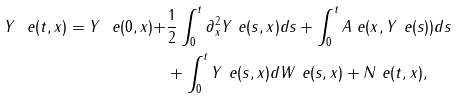Convert formula to latex. <formula><loc_0><loc_0><loc_500><loc_500>Y ^ { \ } e ( t , x ) = Y ^ { \ } e ( 0 , x ) + & \frac { 1 } { 2 } \int _ { 0 } ^ { t } \partial _ { x } ^ { 2 } Y ^ { \ } e ( s , x ) d s + \int _ { 0 } ^ { t } A ^ { \ } e ( x , Y ^ { \ } e ( s ) ) d s \\ & + \int _ { 0 } ^ { t } Y ^ { \ } e ( s , x ) d W ^ { \ } e ( s , x ) + N ^ { \ } e ( t , x ) ,</formula> 